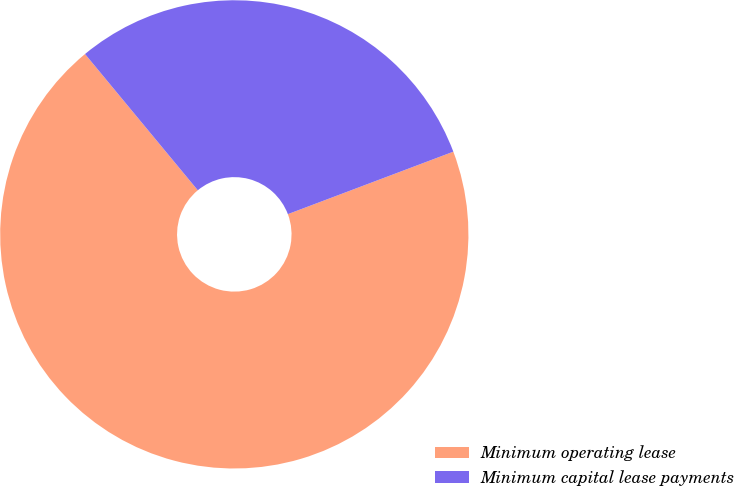<chart> <loc_0><loc_0><loc_500><loc_500><pie_chart><fcel>Minimum operating lease<fcel>Minimum capital lease payments<nl><fcel>69.74%<fcel>30.26%<nl></chart> 